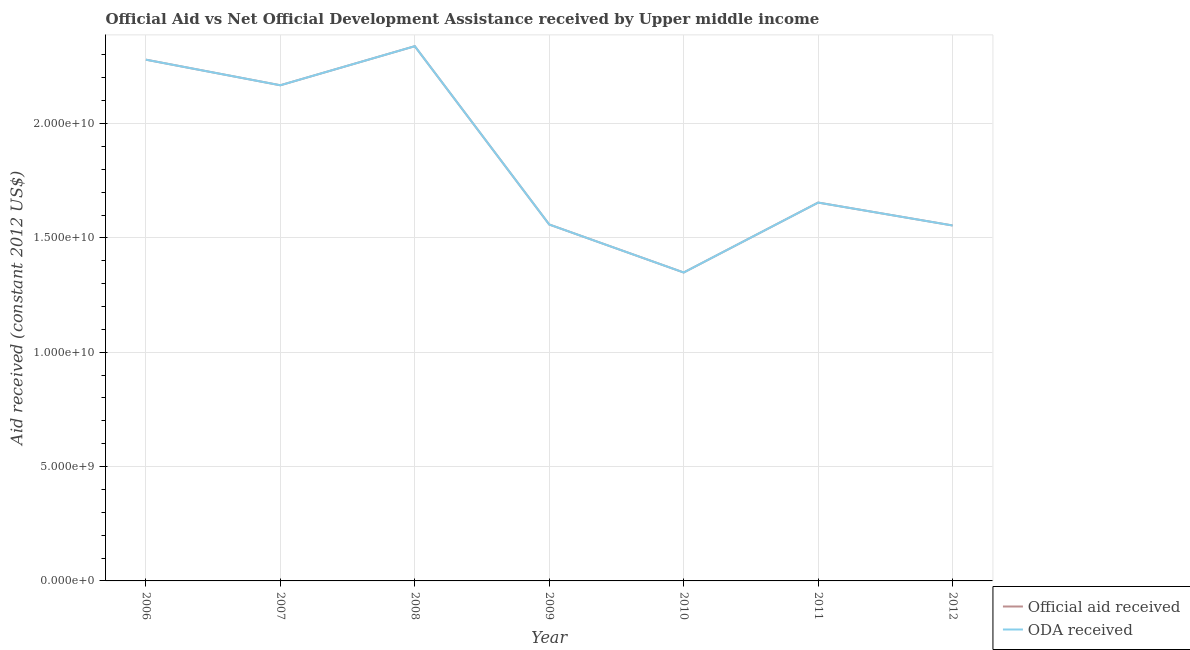Does the line corresponding to official aid received intersect with the line corresponding to oda received?
Provide a short and direct response. Yes. What is the oda received in 2009?
Provide a succinct answer. 1.56e+1. Across all years, what is the maximum oda received?
Your answer should be very brief. 2.34e+1. Across all years, what is the minimum oda received?
Your answer should be compact. 1.35e+1. In which year was the official aid received maximum?
Give a very brief answer. 2008. In which year was the oda received minimum?
Make the answer very short. 2010. What is the total oda received in the graph?
Ensure brevity in your answer.  1.29e+11. What is the difference between the oda received in 2006 and that in 2009?
Ensure brevity in your answer.  7.21e+09. What is the difference between the official aid received in 2010 and the oda received in 2008?
Your answer should be compact. -9.90e+09. What is the average official aid received per year?
Provide a succinct answer. 1.84e+1. In how many years, is the official aid received greater than 16000000000 US$?
Ensure brevity in your answer.  4. What is the ratio of the official aid received in 2006 to that in 2010?
Your response must be concise. 1.69. What is the difference between the highest and the second highest official aid received?
Offer a very short reply. 5.89e+08. What is the difference between the highest and the lowest oda received?
Provide a short and direct response. 9.90e+09. Is the oda received strictly less than the official aid received over the years?
Make the answer very short. No. How many years are there in the graph?
Provide a short and direct response. 7. Are the values on the major ticks of Y-axis written in scientific E-notation?
Your answer should be compact. Yes. Does the graph contain any zero values?
Keep it short and to the point. No. How many legend labels are there?
Offer a very short reply. 2. What is the title of the graph?
Make the answer very short. Official Aid vs Net Official Development Assistance received by Upper middle income . What is the label or title of the Y-axis?
Your answer should be very brief. Aid received (constant 2012 US$). What is the Aid received (constant 2012 US$) in Official aid received in 2006?
Provide a succinct answer. 2.28e+1. What is the Aid received (constant 2012 US$) in ODA received in 2006?
Offer a terse response. 2.28e+1. What is the Aid received (constant 2012 US$) of Official aid received in 2007?
Your answer should be very brief. 2.17e+1. What is the Aid received (constant 2012 US$) of ODA received in 2007?
Your answer should be very brief. 2.17e+1. What is the Aid received (constant 2012 US$) of Official aid received in 2008?
Give a very brief answer. 2.34e+1. What is the Aid received (constant 2012 US$) of ODA received in 2008?
Your response must be concise. 2.34e+1. What is the Aid received (constant 2012 US$) in Official aid received in 2009?
Keep it short and to the point. 1.56e+1. What is the Aid received (constant 2012 US$) of ODA received in 2009?
Ensure brevity in your answer.  1.56e+1. What is the Aid received (constant 2012 US$) in Official aid received in 2010?
Your answer should be very brief. 1.35e+1. What is the Aid received (constant 2012 US$) in ODA received in 2010?
Offer a terse response. 1.35e+1. What is the Aid received (constant 2012 US$) of Official aid received in 2011?
Your answer should be compact. 1.65e+1. What is the Aid received (constant 2012 US$) of ODA received in 2011?
Give a very brief answer. 1.65e+1. What is the Aid received (constant 2012 US$) of Official aid received in 2012?
Your answer should be very brief. 1.55e+1. What is the Aid received (constant 2012 US$) of ODA received in 2012?
Give a very brief answer. 1.55e+1. Across all years, what is the maximum Aid received (constant 2012 US$) in Official aid received?
Provide a succinct answer. 2.34e+1. Across all years, what is the maximum Aid received (constant 2012 US$) of ODA received?
Offer a terse response. 2.34e+1. Across all years, what is the minimum Aid received (constant 2012 US$) in Official aid received?
Provide a succinct answer. 1.35e+1. Across all years, what is the minimum Aid received (constant 2012 US$) of ODA received?
Offer a terse response. 1.35e+1. What is the total Aid received (constant 2012 US$) of Official aid received in the graph?
Your answer should be very brief. 1.29e+11. What is the total Aid received (constant 2012 US$) in ODA received in the graph?
Offer a terse response. 1.29e+11. What is the difference between the Aid received (constant 2012 US$) in Official aid received in 2006 and that in 2007?
Ensure brevity in your answer.  1.12e+09. What is the difference between the Aid received (constant 2012 US$) in ODA received in 2006 and that in 2007?
Ensure brevity in your answer.  1.12e+09. What is the difference between the Aid received (constant 2012 US$) of Official aid received in 2006 and that in 2008?
Offer a terse response. -5.89e+08. What is the difference between the Aid received (constant 2012 US$) of ODA received in 2006 and that in 2008?
Your answer should be compact. -5.89e+08. What is the difference between the Aid received (constant 2012 US$) of Official aid received in 2006 and that in 2009?
Your answer should be very brief. 7.21e+09. What is the difference between the Aid received (constant 2012 US$) in ODA received in 2006 and that in 2009?
Your answer should be compact. 7.21e+09. What is the difference between the Aid received (constant 2012 US$) in Official aid received in 2006 and that in 2010?
Ensure brevity in your answer.  9.31e+09. What is the difference between the Aid received (constant 2012 US$) in ODA received in 2006 and that in 2010?
Give a very brief answer. 9.31e+09. What is the difference between the Aid received (constant 2012 US$) in Official aid received in 2006 and that in 2011?
Give a very brief answer. 6.25e+09. What is the difference between the Aid received (constant 2012 US$) in ODA received in 2006 and that in 2011?
Offer a terse response. 6.25e+09. What is the difference between the Aid received (constant 2012 US$) of Official aid received in 2006 and that in 2012?
Give a very brief answer. 7.25e+09. What is the difference between the Aid received (constant 2012 US$) in ODA received in 2006 and that in 2012?
Your answer should be very brief. 7.25e+09. What is the difference between the Aid received (constant 2012 US$) in Official aid received in 2007 and that in 2008?
Provide a succinct answer. -1.71e+09. What is the difference between the Aid received (constant 2012 US$) of ODA received in 2007 and that in 2008?
Give a very brief answer. -1.71e+09. What is the difference between the Aid received (constant 2012 US$) of Official aid received in 2007 and that in 2009?
Ensure brevity in your answer.  6.09e+09. What is the difference between the Aid received (constant 2012 US$) in ODA received in 2007 and that in 2009?
Offer a very short reply. 6.09e+09. What is the difference between the Aid received (constant 2012 US$) in Official aid received in 2007 and that in 2010?
Your answer should be very brief. 8.19e+09. What is the difference between the Aid received (constant 2012 US$) of ODA received in 2007 and that in 2010?
Make the answer very short. 8.19e+09. What is the difference between the Aid received (constant 2012 US$) of Official aid received in 2007 and that in 2011?
Your answer should be compact. 5.13e+09. What is the difference between the Aid received (constant 2012 US$) in ODA received in 2007 and that in 2011?
Ensure brevity in your answer.  5.13e+09. What is the difference between the Aid received (constant 2012 US$) in Official aid received in 2007 and that in 2012?
Provide a succinct answer. 6.13e+09. What is the difference between the Aid received (constant 2012 US$) of ODA received in 2007 and that in 2012?
Ensure brevity in your answer.  6.13e+09. What is the difference between the Aid received (constant 2012 US$) in Official aid received in 2008 and that in 2009?
Offer a terse response. 7.80e+09. What is the difference between the Aid received (constant 2012 US$) of ODA received in 2008 and that in 2009?
Ensure brevity in your answer.  7.80e+09. What is the difference between the Aid received (constant 2012 US$) of Official aid received in 2008 and that in 2010?
Your answer should be very brief. 9.90e+09. What is the difference between the Aid received (constant 2012 US$) of ODA received in 2008 and that in 2010?
Make the answer very short. 9.90e+09. What is the difference between the Aid received (constant 2012 US$) in Official aid received in 2008 and that in 2011?
Your response must be concise. 6.84e+09. What is the difference between the Aid received (constant 2012 US$) of ODA received in 2008 and that in 2011?
Make the answer very short. 6.84e+09. What is the difference between the Aid received (constant 2012 US$) in Official aid received in 2008 and that in 2012?
Ensure brevity in your answer.  7.84e+09. What is the difference between the Aid received (constant 2012 US$) in ODA received in 2008 and that in 2012?
Your answer should be very brief. 7.84e+09. What is the difference between the Aid received (constant 2012 US$) in Official aid received in 2009 and that in 2010?
Ensure brevity in your answer.  2.10e+09. What is the difference between the Aid received (constant 2012 US$) of ODA received in 2009 and that in 2010?
Offer a terse response. 2.10e+09. What is the difference between the Aid received (constant 2012 US$) in Official aid received in 2009 and that in 2011?
Provide a short and direct response. -9.59e+08. What is the difference between the Aid received (constant 2012 US$) of ODA received in 2009 and that in 2011?
Provide a succinct answer. -9.59e+08. What is the difference between the Aid received (constant 2012 US$) of Official aid received in 2009 and that in 2012?
Make the answer very short. 4.25e+07. What is the difference between the Aid received (constant 2012 US$) in ODA received in 2009 and that in 2012?
Your answer should be very brief. 4.25e+07. What is the difference between the Aid received (constant 2012 US$) of Official aid received in 2010 and that in 2011?
Offer a terse response. -3.06e+09. What is the difference between the Aid received (constant 2012 US$) of ODA received in 2010 and that in 2011?
Your answer should be very brief. -3.06e+09. What is the difference between the Aid received (constant 2012 US$) of Official aid received in 2010 and that in 2012?
Your answer should be compact. -2.06e+09. What is the difference between the Aid received (constant 2012 US$) in ODA received in 2010 and that in 2012?
Keep it short and to the point. -2.06e+09. What is the difference between the Aid received (constant 2012 US$) of Official aid received in 2011 and that in 2012?
Provide a succinct answer. 1.00e+09. What is the difference between the Aid received (constant 2012 US$) in ODA received in 2011 and that in 2012?
Your answer should be very brief. 1.00e+09. What is the difference between the Aid received (constant 2012 US$) of Official aid received in 2006 and the Aid received (constant 2012 US$) of ODA received in 2007?
Provide a short and direct response. 1.12e+09. What is the difference between the Aid received (constant 2012 US$) of Official aid received in 2006 and the Aid received (constant 2012 US$) of ODA received in 2008?
Provide a succinct answer. -5.89e+08. What is the difference between the Aid received (constant 2012 US$) in Official aid received in 2006 and the Aid received (constant 2012 US$) in ODA received in 2009?
Make the answer very short. 7.21e+09. What is the difference between the Aid received (constant 2012 US$) of Official aid received in 2006 and the Aid received (constant 2012 US$) of ODA received in 2010?
Provide a succinct answer. 9.31e+09. What is the difference between the Aid received (constant 2012 US$) of Official aid received in 2006 and the Aid received (constant 2012 US$) of ODA received in 2011?
Offer a terse response. 6.25e+09. What is the difference between the Aid received (constant 2012 US$) of Official aid received in 2006 and the Aid received (constant 2012 US$) of ODA received in 2012?
Ensure brevity in your answer.  7.25e+09. What is the difference between the Aid received (constant 2012 US$) of Official aid received in 2007 and the Aid received (constant 2012 US$) of ODA received in 2008?
Your answer should be compact. -1.71e+09. What is the difference between the Aid received (constant 2012 US$) of Official aid received in 2007 and the Aid received (constant 2012 US$) of ODA received in 2009?
Your answer should be very brief. 6.09e+09. What is the difference between the Aid received (constant 2012 US$) of Official aid received in 2007 and the Aid received (constant 2012 US$) of ODA received in 2010?
Give a very brief answer. 8.19e+09. What is the difference between the Aid received (constant 2012 US$) of Official aid received in 2007 and the Aid received (constant 2012 US$) of ODA received in 2011?
Make the answer very short. 5.13e+09. What is the difference between the Aid received (constant 2012 US$) of Official aid received in 2007 and the Aid received (constant 2012 US$) of ODA received in 2012?
Offer a terse response. 6.13e+09. What is the difference between the Aid received (constant 2012 US$) in Official aid received in 2008 and the Aid received (constant 2012 US$) in ODA received in 2009?
Ensure brevity in your answer.  7.80e+09. What is the difference between the Aid received (constant 2012 US$) in Official aid received in 2008 and the Aid received (constant 2012 US$) in ODA received in 2010?
Your response must be concise. 9.90e+09. What is the difference between the Aid received (constant 2012 US$) of Official aid received in 2008 and the Aid received (constant 2012 US$) of ODA received in 2011?
Keep it short and to the point. 6.84e+09. What is the difference between the Aid received (constant 2012 US$) in Official aid received in 2008 and the Aid received (constant 2012 US$) in ODA received in 2012?
Your response must be concise. 7.84e+09. What is the difference between the Aid received (constant 2012 US$) of Official aid received in 2009 and the Aid received (constant 2012 US$) of ODA received in 2010?
Keep it short and to the point. 2.10e+09. What is the difference between the Aid received (constant 2012 US$) in Official aid received in 2009 and the Aid received (constant 2012 US$) in ODA received in 2011?
Your answer should be compact. -9.59e+08. What is the difference between the Aid received (constant 2012 US$) in Official aid received in 2009 and the Aid received (constant 2012 US$) in ODA received in 2012?
Ensure brevity in your answer.  4.25e+07. What is the difference between the Aid received (constant 2012 US$) of Official aid received in 2010 and the Aid received (constant 2012 US$) of ODA received in 2011?
Your answer should be very brief. -3.06e+09. What is the difference between the Aid received (constant 2012 US$) in Official aid received in 2010 and the Aid received (constant 2012 US$) in ODA received in 2012?
Your response must be concise. -2.06e+09. What is the difference between the Aid received (constant 2012 US$) of Official aid received in 2011 and the Aid received (constant 2012 US$) of ODA received in 2012?
Offer a very short reply. 1.00e+09. What is the average Aid received (constant 2012 US$) in Official aid received per year?
Give a very brief answer. 1.84e+1. What is the average Aid received (constant 2012 US$) of ODA received per year?
Your answer should be very brief. 1.84e+1. In the year 2009, what is the difference between the Aid received (constant 2012 US$) in Official aid received and Aid received (constant 2012 US$) in ODA received?
Give a very brief answer. 0. In the year 2010, what is the difference between the Aid received (constant 2012 US$) in Official aid received and Aid received (constant 2012 US$) in ODA received?
Provide a short and direct response. 0. In the year 2011, what is the difference between the Aid received (constant 2012 US$) in Official aid received and Aid received (constant 2012 US$) in ODA received?
Make the answer very short. 0. What is the ratio of the Aid received (constant 2012 US$) of Official aid received in 2006 to that in 2007?
Your answer should be compact. 1.05. What is the ratio of the Aid received (constant 2012 US$) of ODA received in 2006 to that in 2007?
Provide a short and direct response. 1.05. What is the ratio of the Aid received (constant 2012 US$) in Official aid received in 2006 to that in 2008?
Your answer should be very brief. 0.97. What is the ratio of the Aid received (constant 2012 US$) of ODA received in 2006 to that in 2008?
Offer a terse response. 0.97. What is the ratio of the Aid received (constant 2012 US$) of Official aid received in 2006 to that in 2009?
Give a very brief answer. 1.46. What is the ratio of the Aid received (constant 2012 US$) in ODA received in 2006 to that in 2009?
Provide a succinct answer. 1.46. What is the ratio of the Aid received (constant 2012 US$) of Official aid received in 2006 to that in 2010?
Provide a succinct answer. 1.69. What is the ratio of the Aid received (constant 2012 US$) in ODA received in 2006 to that in 2010?
Provide a succinct answer. 1.69. What is the ratio of the Aid received (constant 2012 US$) in Official aid received in 2006 to that in 2011?
Offer a very short reply. 1.38. What is the ratio of the Aid received (constant 2012 US$) of ODA received in 2006 to that in 2011?
Offer a terse response. 1.38. What is the ratio of the Aid received (constant 2012 US$) of Official aid received in 2006 to that in 2012?
Your answer should be very brief. 1.47. What is the ratio of the Aid received (constant 2012 US$) of ODA received in 2006 to that in 2012?
Provide a short and direct response. 1.47. What is the ratio of the Aid received (constant 2012 US$) in Official aid received in 2007 to that in 2008?
Offer a very short reply. 0.93. What is the ratio of the Aid received (constant 2012 US$) of ODA received in 2007 to that in 2008?
Make the answer very short. 0.93. What is the ratio of the Aid received (constant 2012 US$) of Official aid received in 2007 to that in 2009?
Provide a succinct answer. 1.39. What is the ratio of the Aid received (constant 2012 US$) in ODA received in 2007 to that in 2009?
Provide a short and direct response. 1.39. What is the ratio of the Aid received (constant 2012 US$) in Official aid received in 2007 to that in 2010?
Offer a very short reply. 1.61. What is the ratio of the Aid received (constant 2012 US$) of ODA received in 2007 to that in 2010?
Make the answer very short. 1.61. What is the ratio of the Aid received (constant 2012 US$) in Official aid received in 2007 to that in 2011?
Your answer should be very brief. 1.31. What is the ratio of the Aid received (constant 2012 US$) in ODA received in 2007 to that in 2011?
Offer a very short reply. 1.31. What is the ratio of the Aid received (constant 2012 US$) of Official aid received in 2007 to that in 2012?
Your answer should be compact. 1.39. What is the ratio of the Aid received (constant 2012 US$) in ODA received in 2007 to that in 2012?
Ensure brevity in your answer.  1.39. What is the ratio of the Aid received (constant 2012 US$) of Official aid received in 2008 to that in 2009?
Offer a terse response. 1.5. What is the ratio of the Aid received (constant 2012 US$) of ODA received in 2008 to that in 2009?
Make the answer very short. 1.5. What is the ratio of the Aid received (constant 2012 US$) in Official aid received in 2008 to that in 2010?
Provide a short and direct response. 1.73. What is the ratio of the Aid received (constant 2012 US$) in ODA received in 2008 to that in 2010?
Your answer should be very brief. 1.73. What is the ratio of the Aid received (constant 2012 US$) of Official aid received in 2008 to that in 2011?
Your answer should be very brief. 1.41. What is the ratio of the Aid received (constant 2012 US$) of ODA received in 2008 to that in 2011?
Your answer should be very brief. 1.41. What is the ratio of the Aid received (constant 2012 US$) in Official aid received in 2008 to that in 2012?
Offer a very short reply. 1.5. What is the ratio of the Aid received (constant 2012 US$) in ODA received in 2008 to that in 2012?
Provide a short and direct response. 1.5. What is the ratio of the Aid received (constant 2012 US$) of Official aid received in 2009 to that in 2010?
Provide a succinct answer. 1.16. What is the ratio of the Aid received (constant 2012 US$) of ODA received in 2009 to that in 2010?
Keep it short and to the point. 1.16. What is the ratio of the Aid received (constant 2012 US$) in Official aid received in 2009 to that in 2011?
Make the answer very short. 0.94. What is the ratio of the Aid received (constant 2012 US$) of ODA received in 2009 to that in 2011?
Your answer should be compact. 0.94. What is the ratio of the Aid received (constant 2012 US$) of Official aid received in 2010 to that in 2011?
Your answer should be compact. 0.82. What is the ratio of the Aid received (constant 2012 US$) of ODA received in 2010 to that in 2011?
Provide a short and direct response. 0.82. What is the ratio of the Aid received (constant 2012 US$) in Official aid received in 2010 to that in 2012?
Ensure brevity in your answer.  0.87. What is the ratio of the Aid received (constant 2012 US$) of ODA received in 2010 to that in 2012?
Provide a short and direct response. 0.87. What is the ratio of the Aid received (constant 2012 US$) in Official aid received in 2011 to that in 2012?
Offer a very short reply. 1.06. What is the ratio of the Aid received (constant 2012 US$) of ODA received in 2011 to that in 2012?
Offer a very short reply. 1.06. What is the difference between the highest and the second highest Aid received (constant 2012 US$) of Official aid received?
Offer a terse response. 5.89e+08. What is the difference between the highest and the second highest Aid received (constant 2012 US$) of ODA received?
Ensure brevity in your answer.  5.89e+08. What is the difference between the highest and the lowest Aid received (constant 2012 US$) in Official aid received?
Offer a very short reply. 9.90e+09. What is the difference between the highest and the lowest Aid received (constant 2012 US$) of ODA received?
Give a very brief answer. 9.90e+09. 